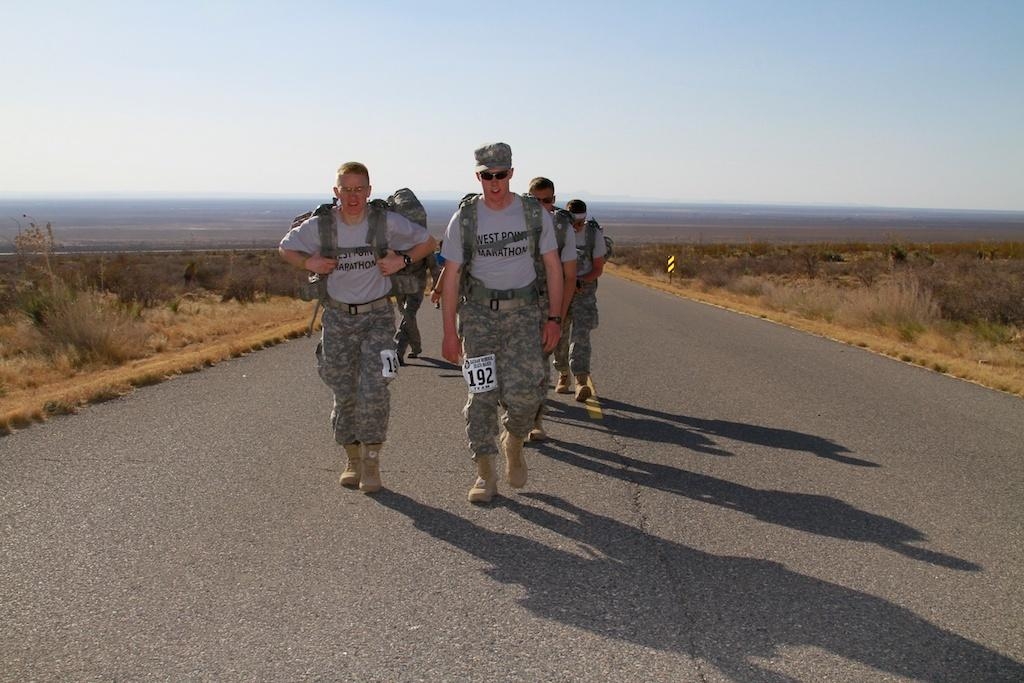What are the people in the image doing? The people in the image are walking on the road. What type of vegetation is present on both sides of the road? There is grass on both sides of the road. What can be seen in the background of the image? The sky is visible in the background of the image. What type of mint is growing in the dirt on the side of the road? There is no mint or dirt visible in the image; it only shows people walking on the road with grass on both sides. 